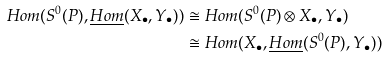Convert formula to latex. <formula><loc_0><loc_0><loc_500><loc_500>H o m ( S ^ { 0 } ( P ) , \underline { H o m } ( X _ { \bullet } , Y _ { \bullet } ) ) & \cong H o m ( S ^ { 0 } ( P ) \otimes X _ { \bullet } , Y _ { \bullet } ) \\ & \cong H o m ( X _ { \bullet } , \underline { H o m } ( S ^ { 0 } ( P ) , Y _ { \bullet } ) )</formula> 